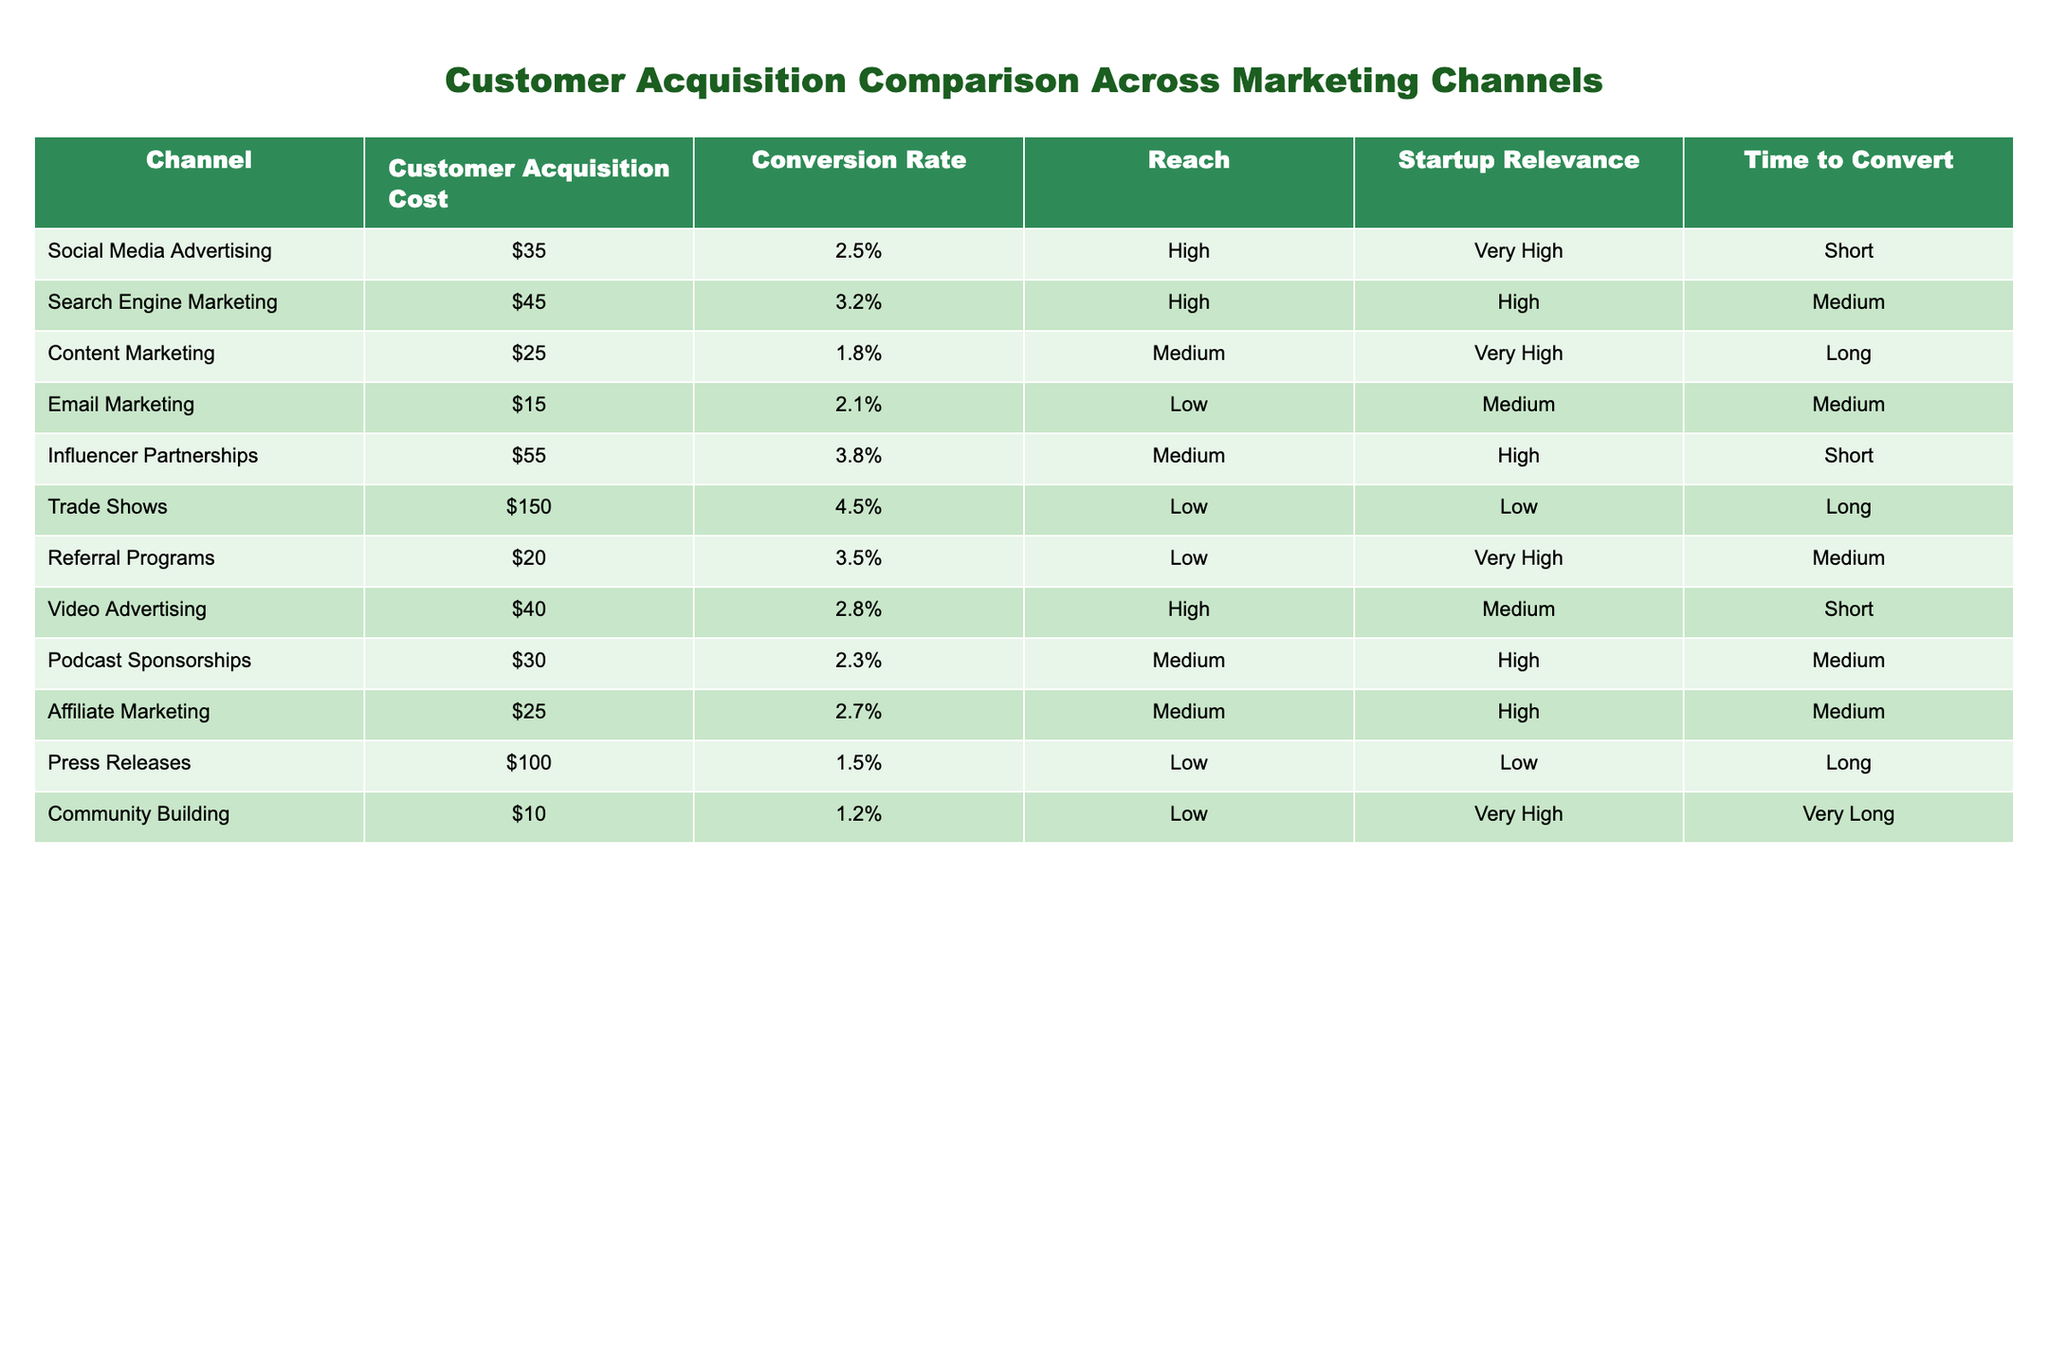What is the Customer Acquisition Cost for Email Marketing? The data for Email Marketing lists the Customer Acquisition Cost as $15.
Answer: $15 Which marketing channel has the highest Conversion Rate? The table shows the Conversion Rates for all channels, and the highest is 4.5% for Trade Shows.
Answer: Trade Shows What is the average Customer Acquisition Cost of Social Media Advertising and Video Advertising? The Customer Acquisition Cost for Social Media Advertising is $35, and for Video Advertising, it's $40. Adding these gives $35 + $40 = $75. Dividing by 2 gives an average of $75/2 = $37.5.
Answer: $37.5 Is the Customer Acquisition Cost for Content Marketing less than $30? The Customer Acquisition Cost for Content Marketing is $25, which is indeed less than $30.
Answer: Yes Which channels have a very high relevance for startups? The channels marked with "Very High" under Startup Relevance are Social Media Advertising, Content Marketing, Referral Programs, and Community Building.
Answer: Social Media Advertising, Content Marketing, Referral Programs, Community Building What is the reach rate for Email Marketing? For Email Marketing, the Reach is categorized as "Low".
Answer: Low If the channels with a low Startup Relevance are eliminated, what would be the average Customer Acquisition Cost of the remaining channels? The remaining channels with high relevance are Social Media Advertising ($35), Search Engine Marketing ($45), Content Marketing ($25), Video Advertising ($40), Podcast Sponsorships ($30), Affiliate Marketing ($25), and Referral Programs ($20). Adding these gives $35 + $45 + $25 + $40 + $30 + $25 + $20 = $250. There are 7 channels, so the average is $250/7 = $35.71.
Answer: $35.71 Is Influencer Partnerships more expensive than Affiliate Marketing in terms of Customer Acquisition Cost? Influencer Partnerships have a Customer Acquisition Cost of $55, while Affiliate Marketing has a cost of $25. Since $55 is greater than $25, the statement is true.
Answer: Yes What is the time to convert for Community Building? The data shows that the time to convert for Community Building is categorized as "Very Long".
Answer: Very Long 